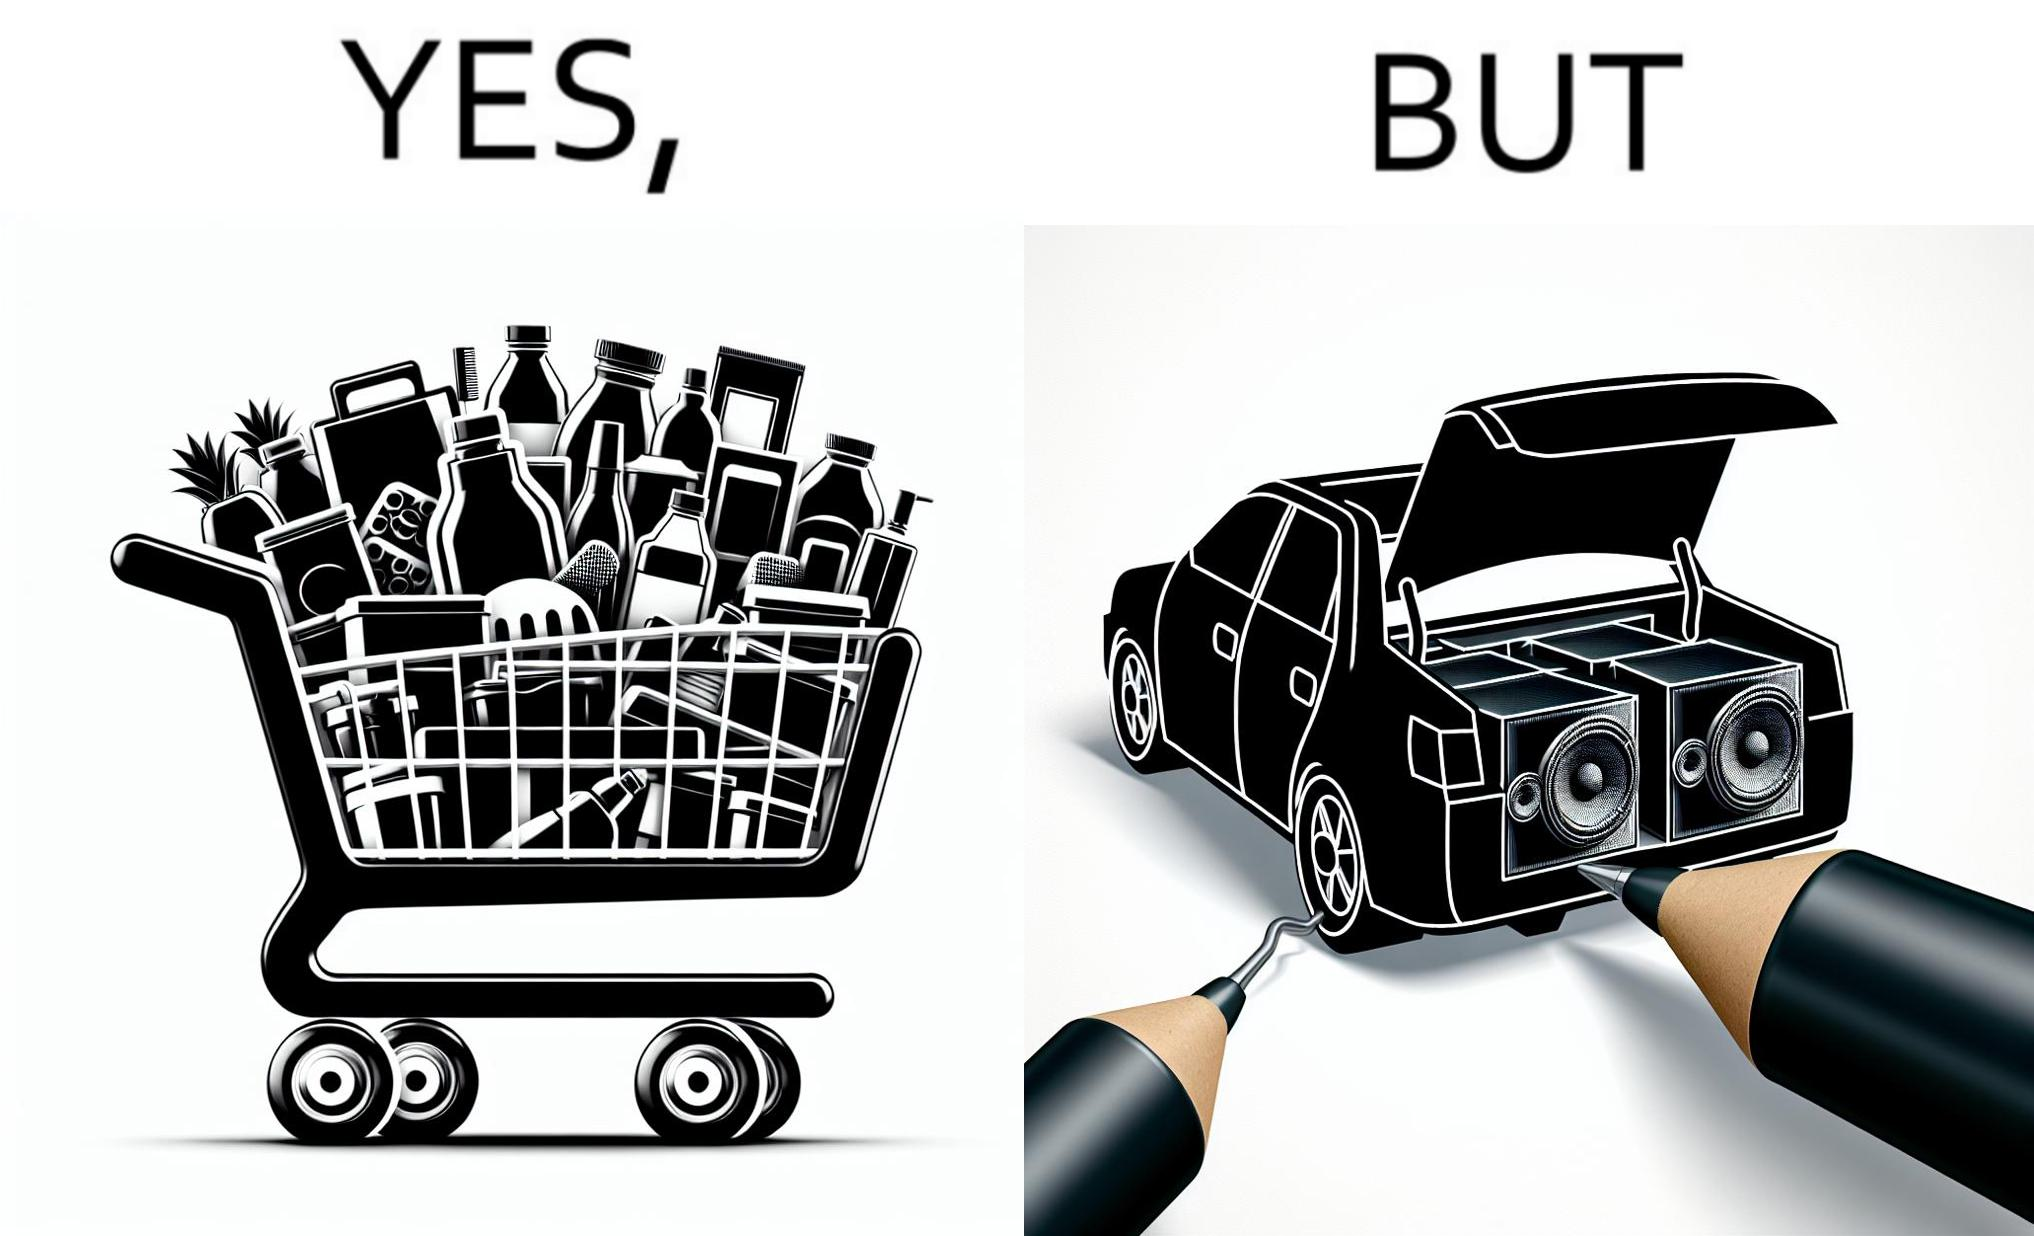Explain the humor or irony in this image. The image is ironic, because a car trunk was earlier designed to keep some extra luggage or things but people nowadays get speakers installed in the trunk which in turn reduces the space in the trunk and making it difficult for people to store the extra luggage in the trunk 